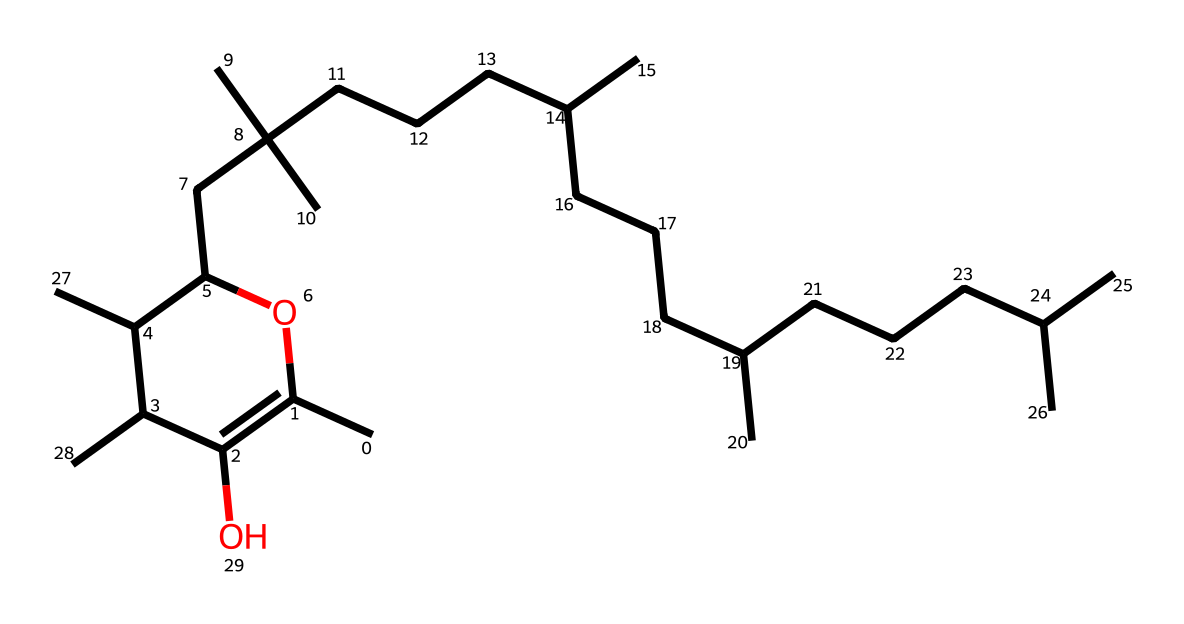What is the main functional group in this vitamin? The structure shows the presence of hydroxyl groups (-OH) attached to carbon atoms, indicating that the main functional group is hydroxyl.
Answer: hydroxyl How many carbon atoms are present in the structure? By counting the carbon atoms in the structure, we note the presence of 20 carbon atoms as they are all connected in the carbon backbone.
Answer: 20 What type of vitamin does this chemical structure represent? The structure is characteristic of tocopherols, specifically vitamin E, which is well-known for its antioxidant properties.
Answer: vitamin E What is the primary role of vitamin E in biological systems? Vitamin E primarily functions as an antioxidant, protecting cells from oxidative damage by neutralizing free radicals.
Answer: antioxidant Does this vitamin contain any double bonds within its structure? Upon analyzing the structure, it is observed that there are several double bonds present between carbon atoms, which is a typical feature of unsaturated fats found in vitamin E.
Answer: yes How many hydroxyl groups are present in this chemical? By examining the structure, we see there are two hydroxyl groups (indicated by -OH) attached, which contribute to its reactivity.
Answer: 2 